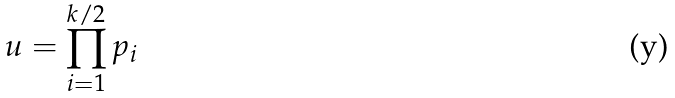<formula> <loc_0><loc_0><loc_500><loc_500>u = \prod _ { i = 1 } ^ { k / 2 } p _ { i }</formula> 